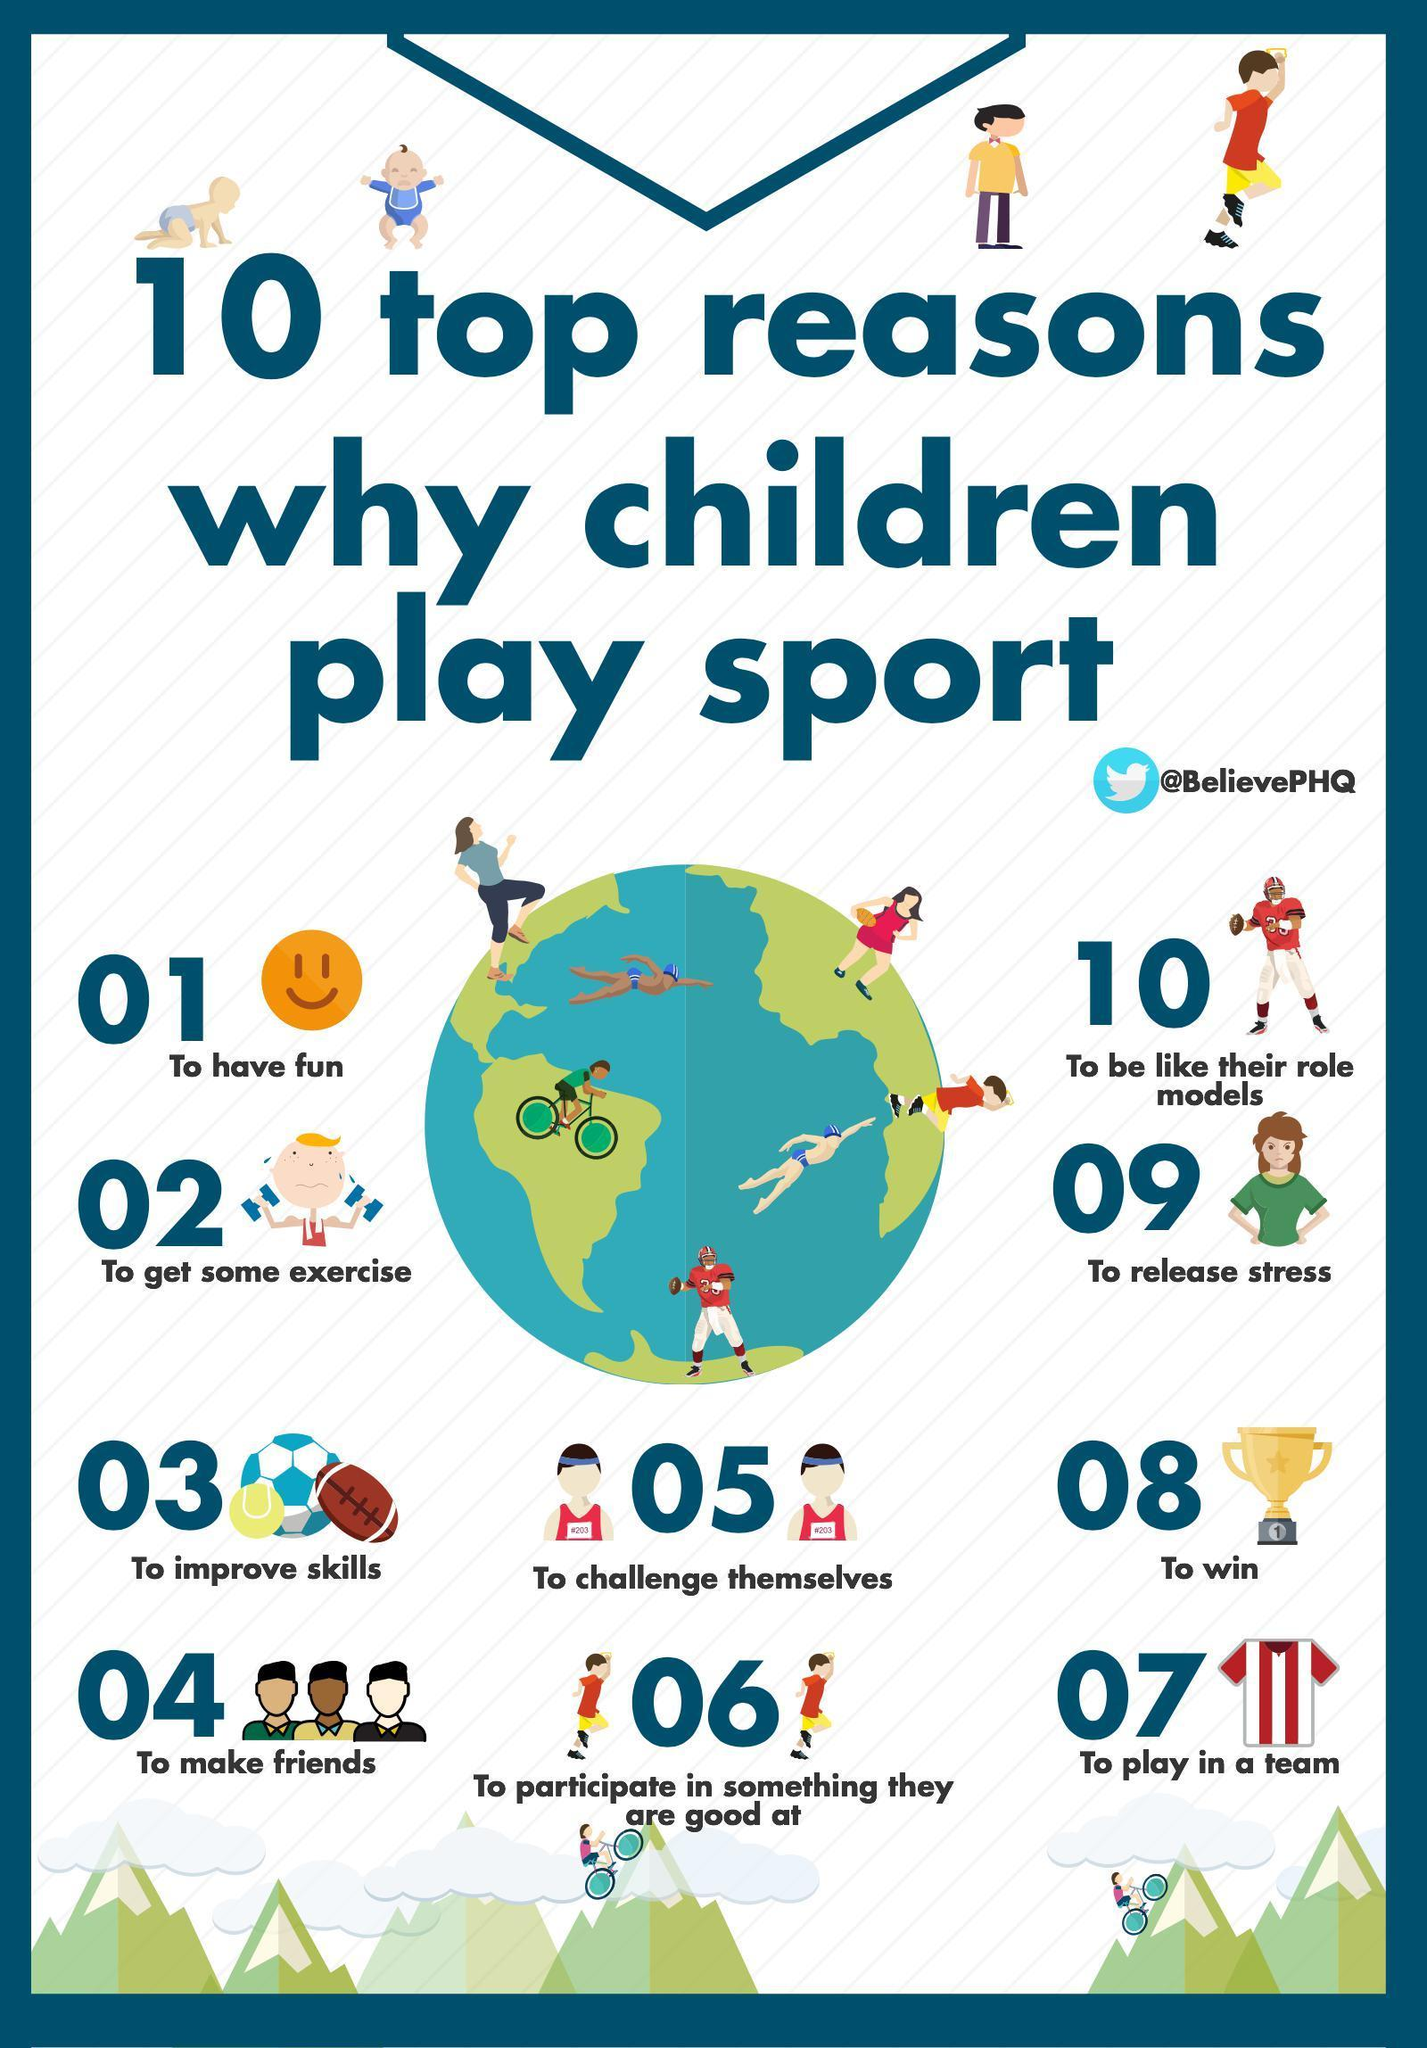What is the eighth reason children love to play?
Answer the question with a short phrase. To win What ranks as the seventh reason for playing? To play in a team Which position does playing helps reducing tension appear, ninth, sixth, or second? ninth 